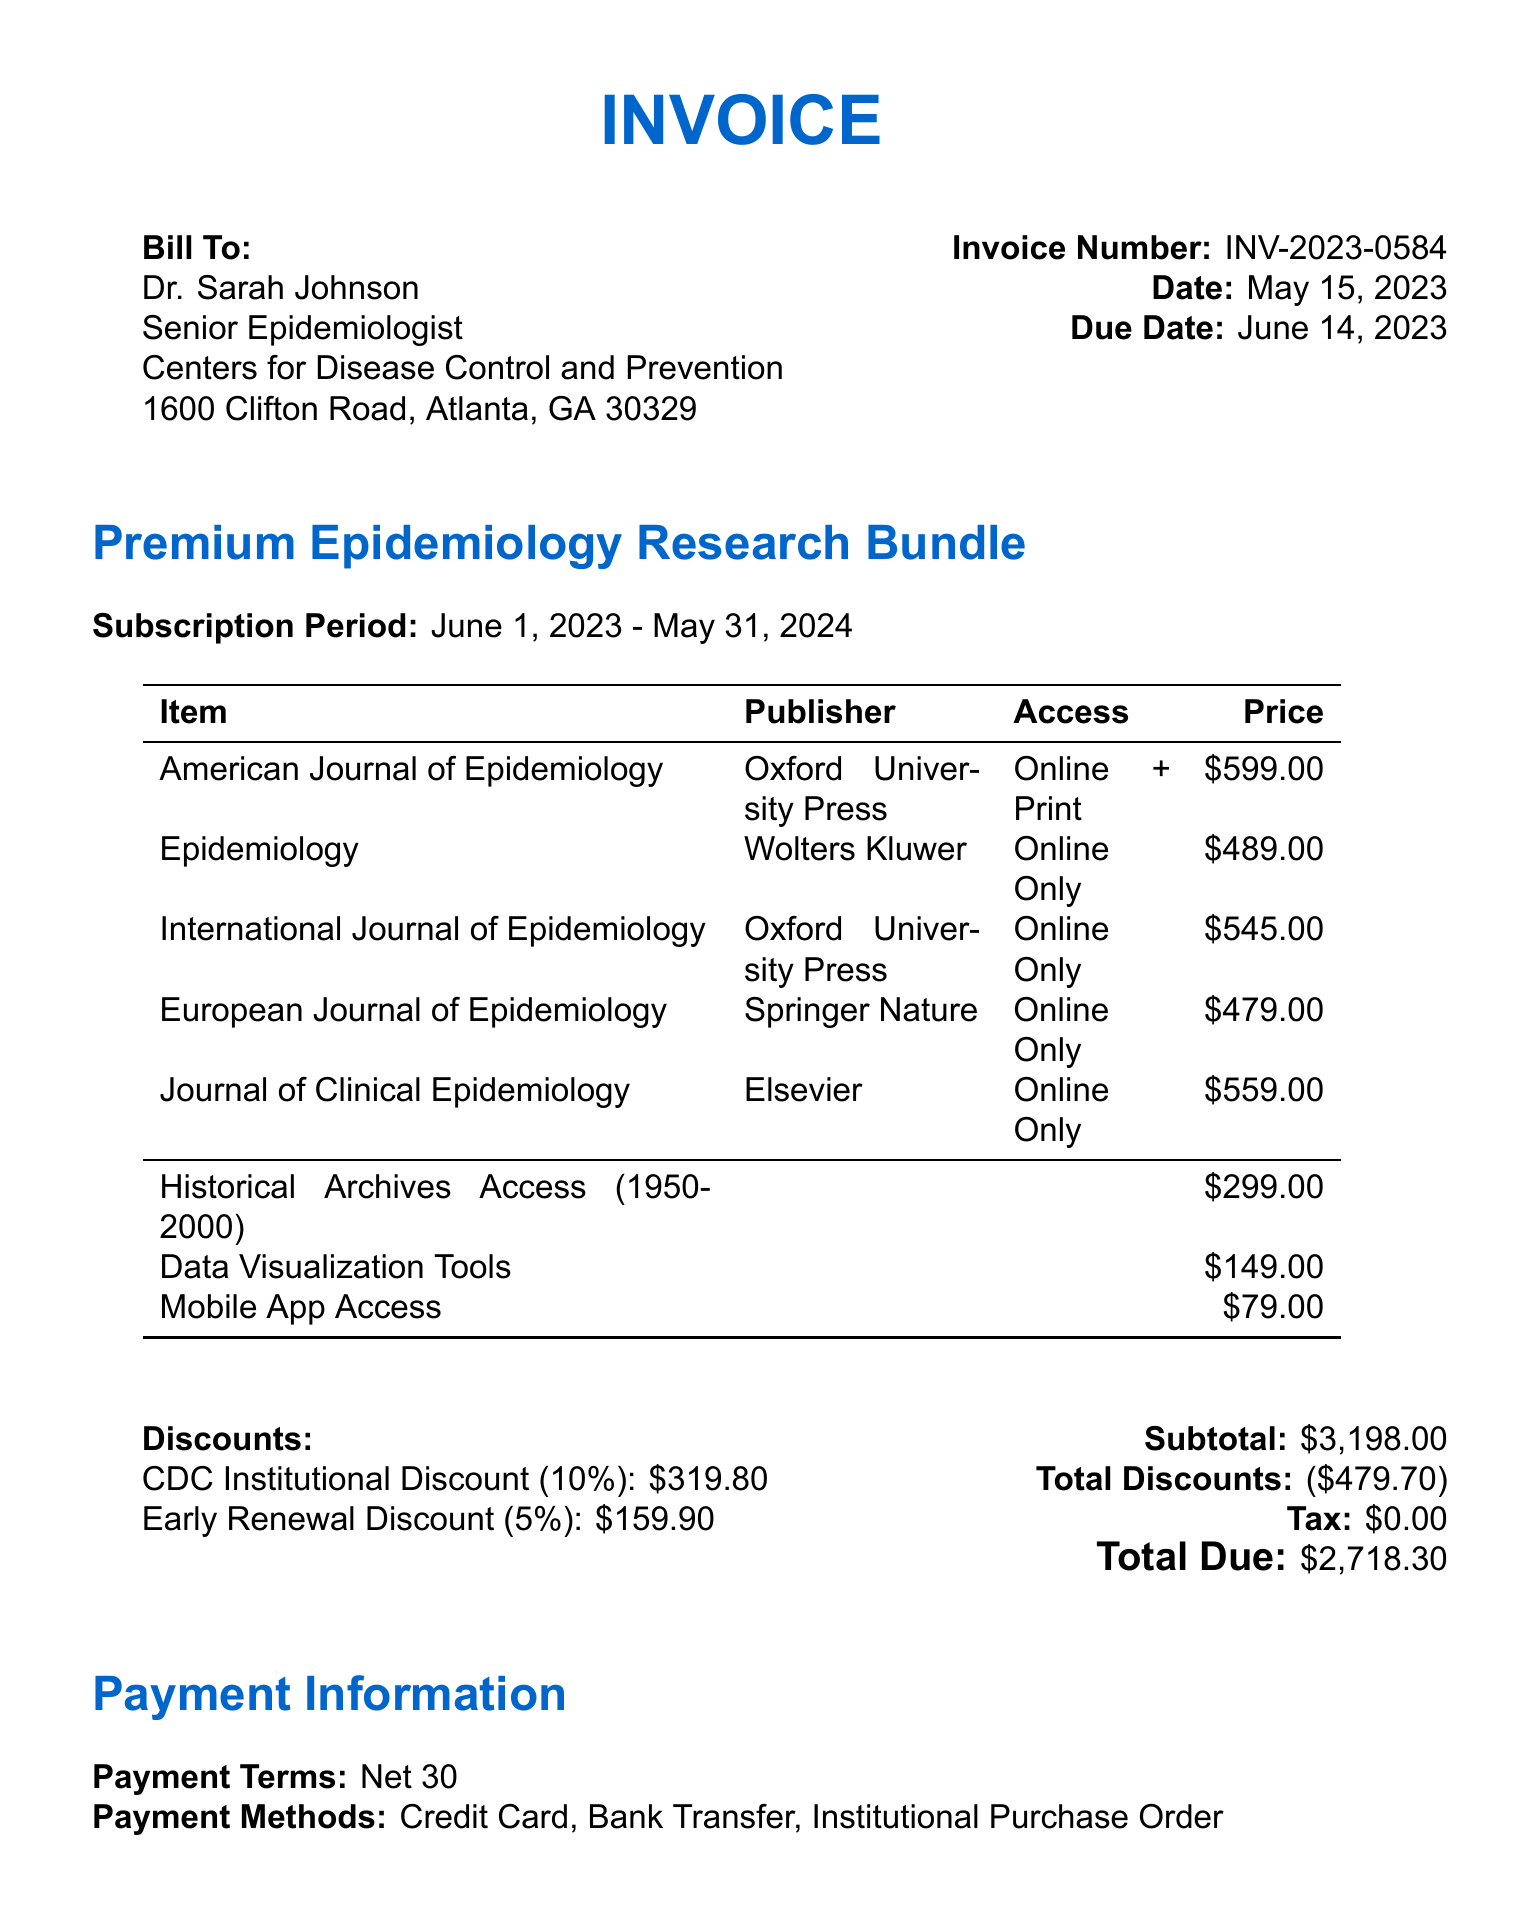What is the invoice number? The invoice number is explicitly stated in the document as INV-2023-0584.
Answer: INV-2023-0584 Who is the bill recipient? The document lists Dr. Sarah Johnson as the bill recipient.
Answer: Dr. Sarah Johnson What is the total amount due? The total amount due is explicitly mentioned in the invoice as $2718.30.
Answer: $2718.30 What is the subscription period? The subscription period is detailed in the document as June 1, 2023 - May 31, 2024.
Answer: June 1, 2023 - May 31, 2024 What is the percentage of the early renewal discount? The early renewal discount percentage is stated as 5%.
Answer: 5% How many users can access the subscription package? The document notes that up to 50 users can access the subscription package.
Answer: 50 users What is the subtotal before discounts? The subtotal before applying discounts is stated as $3198.00.
Answer: $3198.00 What payment methods are accepted? The payment methods mentioned in the document include Credit Card, Bank Transfer, and Institutional Purchase Order.
Answer: Credit Card, Bank Transfer, Institutional Purchase Order What is included in the additional features? The additional features include Historical Archives Access, Data Visualization Tools, and Mobile App Access.
Answer: Historical Archives Access, Data Visualization Tools, Mobile App Access 